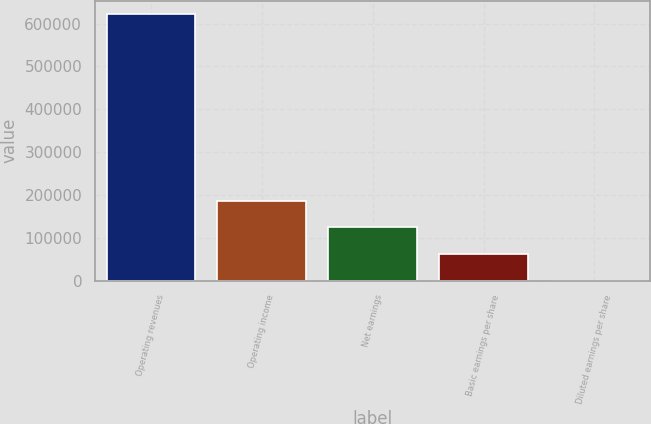<chart> <loc_0><loc_0><loc_500><loc_500><bar_chart><fcel>Operating revenues<fcel>Operating income<fcel>Net earnings<fcel>Basic earnings per share<fcel>Diluted earnings per share<nl><fcel>621644<fcel>186493<fcel>124329<fcel>62164.8<fcel>0.4<nl></chart> 